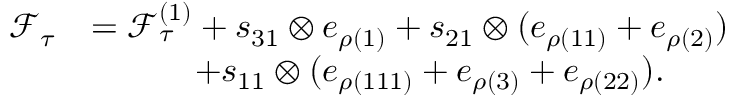<formula> <loc_0><loc_0><loc_500><loc_500>\begin{array} { r l } { \mathcal { F } _ { \tau } } & { = \mathcal { F } _ { \tau } ^ { ( 1 ) } + s _ { 3 1 } \otimes e _ { \rho ( { 1 } ) } + s _ { 2 1 } \otimes ( e _ { \rho ( { 1 1 } ) } + e _ { \rho ( { 2 } ) } ) } \\ & { \quad + s _ { 1 1 } \otimes ( e _ { \rho ( { 1 1 1 } ) } + e _ { \rho ( { 3 } ) } + e _ { \rho ( { 2 2 } ) } ) . } \end{array}</formula> 